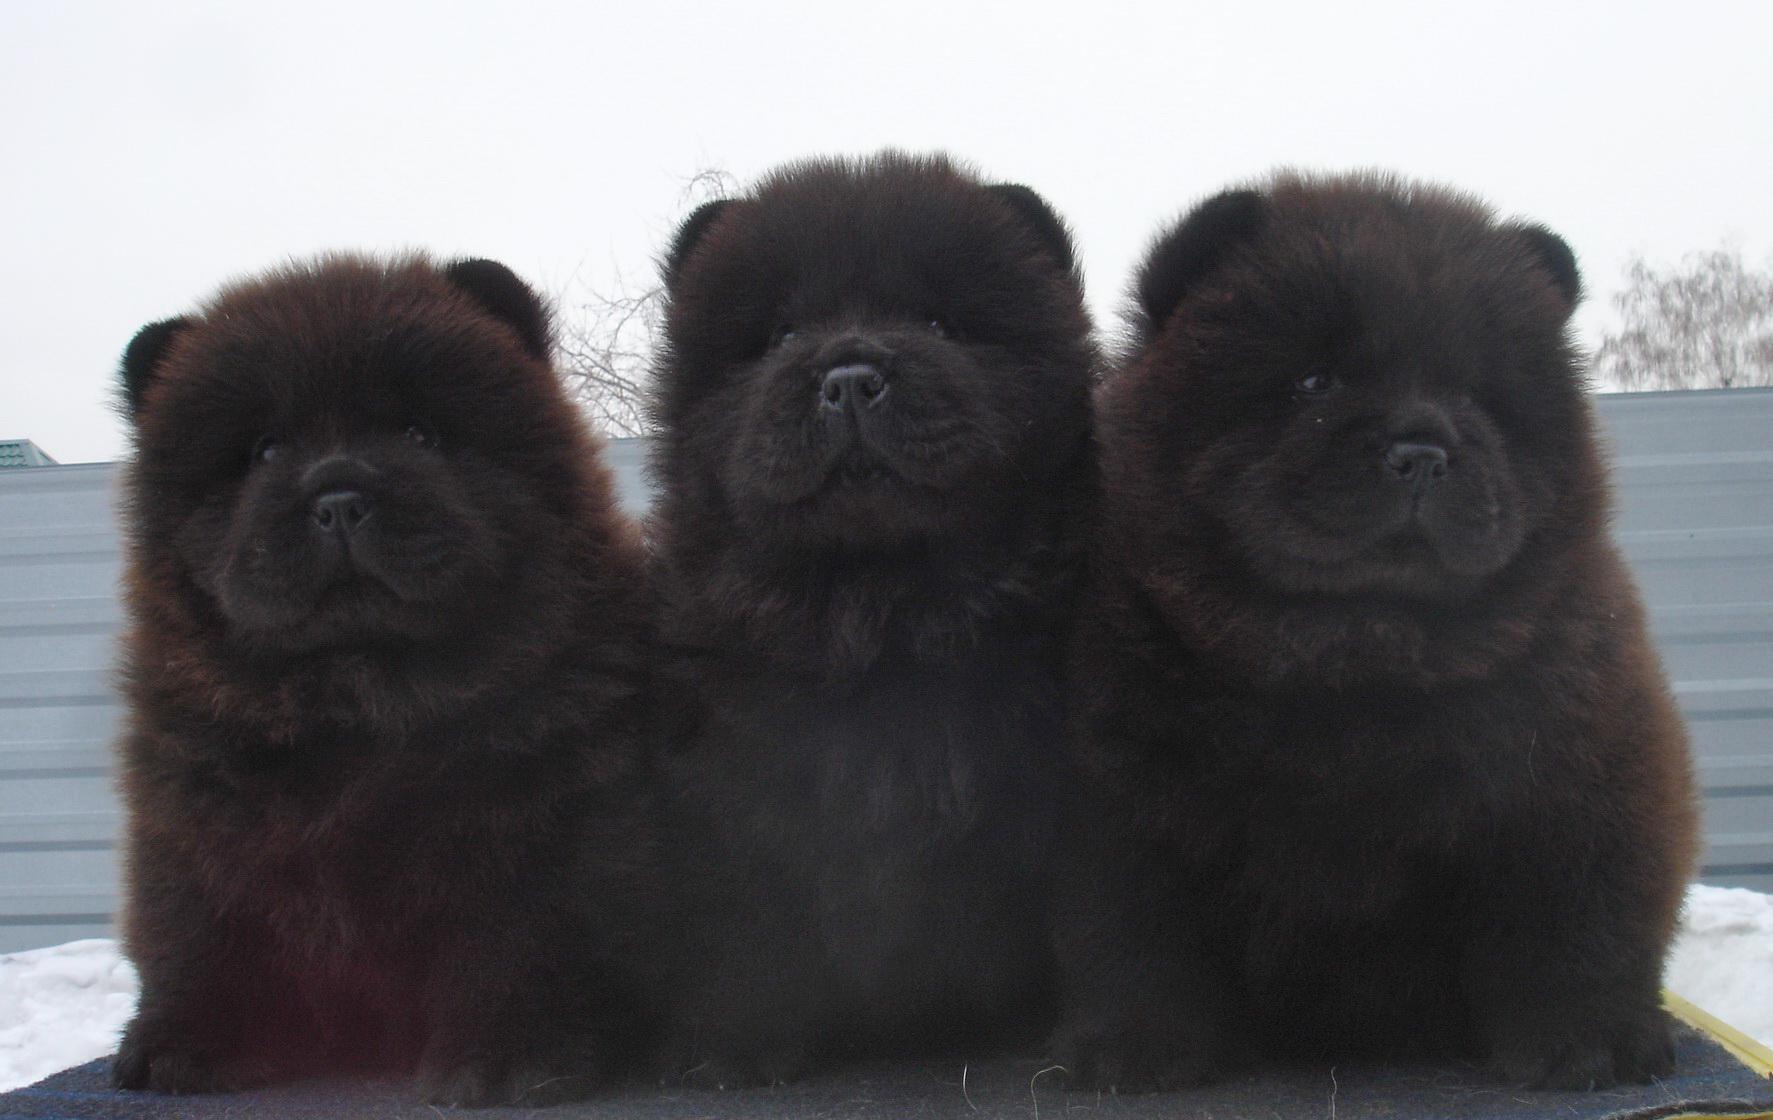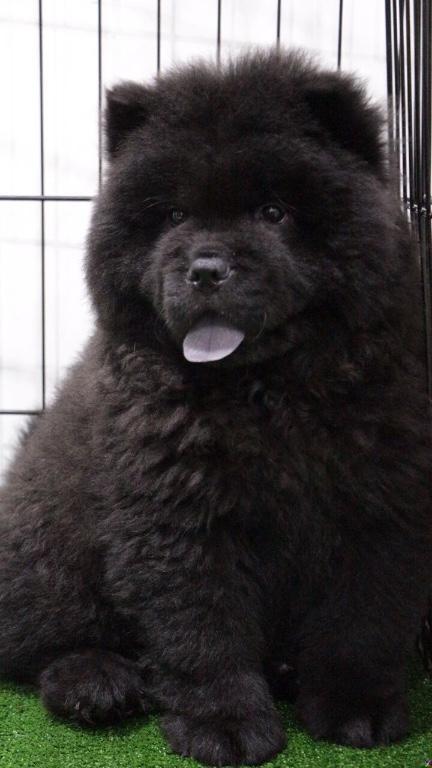The first image is the image on the left, the second image is the image on the right. For the images shown, is this caption "There are only two dogs and no humans." true? Answer yes or no. No. The first image is the image on the left, the second image is the image on the right. For the images shown, is this caption "An image shows rectangular wire 'mesh' behind one black chow dog." true? Answer yes or no. Yes. 